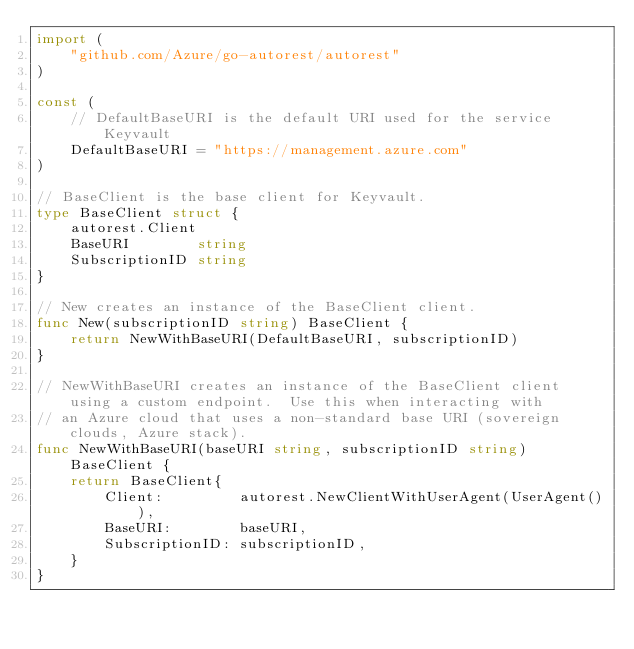<code> <loc_0><loc_0><loc_500><loc_500><_Go_>import (
	"github.com/Azure/go-autorest/autorest"
)

const (
	// DefaultBaseURI is the default URI used for the service Keyvault
	DefaultBaseURI = "https://management.azure.com"
)

// BaseClient is the base client for Keyvault.
type BaseClient struct {
	autorest.Client
	BaseURI        string
	SubscriptionID string
}

// New creates an instance of the BaseClient client.
func New(subscriptionID string) BaseClient {
	return NewWithBaseURI(DefaultBaseURI, subscriptionID)
}

// NewWithBaseURI creates an instance of the BaseClient client using a custom endpoint.  Use this when interacting with
// an Azure cloud that uses a non-standard base URI (sovereign clouds, Azure stack).
func NewWithBaseURI(baseURI string, subscriptionID string) BaseClient {
	return BaseClient{
		Client:         autorest.NewClientWithUserAgent(UserAgent()),
		BaseURI:        baseURI,
		SubscriptionID: subscriptionID,
	}
}
</code> 